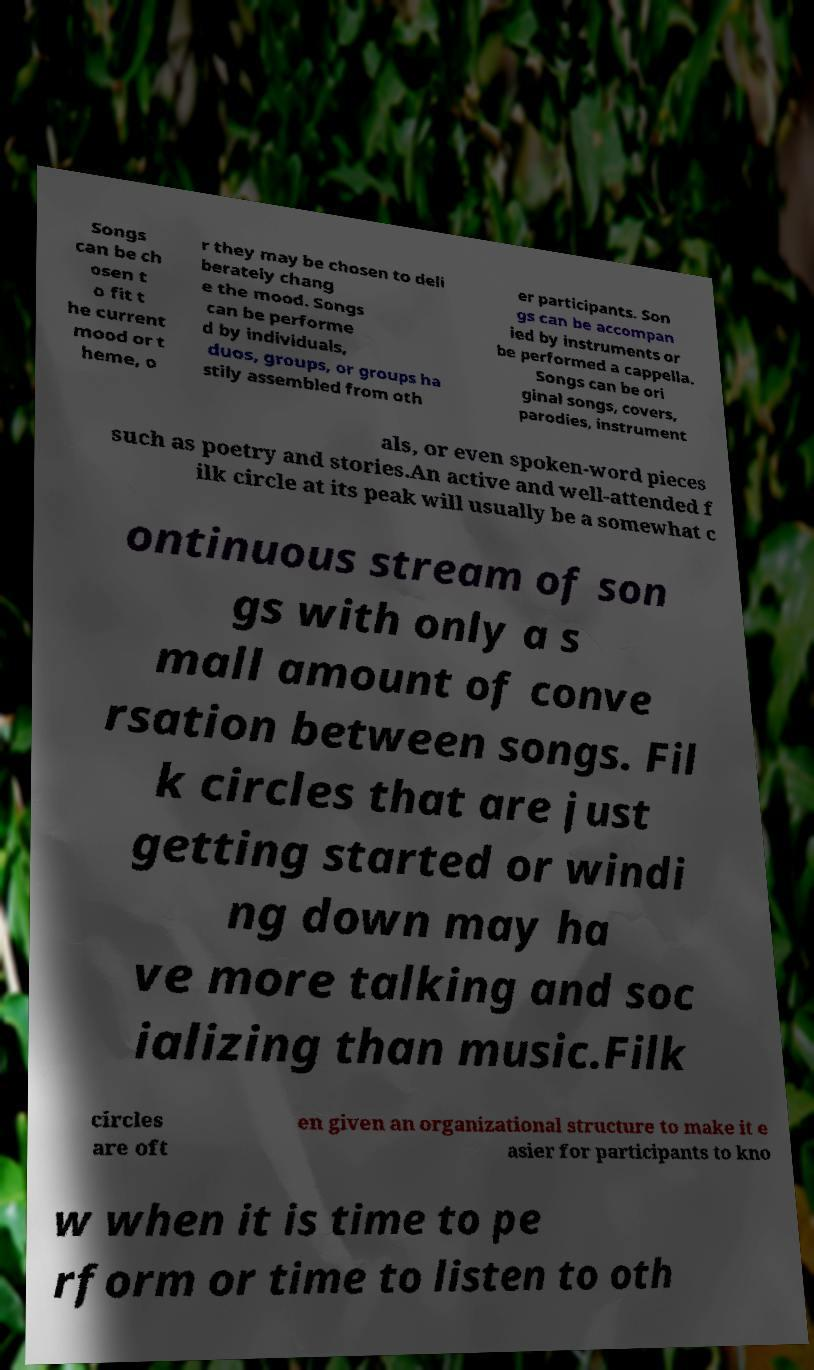Could you assist in decoding the text presented in this image and type it out clearly? Songs can be ch osen t o fit t he current mood or t heme, o r they may be chosen to deli berately chang e the mood. Songs can be performe d by individuals, duos, groups, or groups ha stily assembled from oth er participants. Son gs can be accompan ied by instruments or be performed a cappella. Songs can be ori ginal songs, covers, parodies, instrument als, or even spoken-word pieces such as poetry and stories.An active and well-attended f ilk circle at its peak will usually be a somewhat c ontinuous stream of son gs with only a s mall amount of conve rsation between songs. Fil k circles that are just getting started or windi ng down may ha ve more talking and soc ializing than music.Filk circles are oft en given an organizational structure to make it e asier for participants to kno w when it is time to pe rform or time to listen to oth 